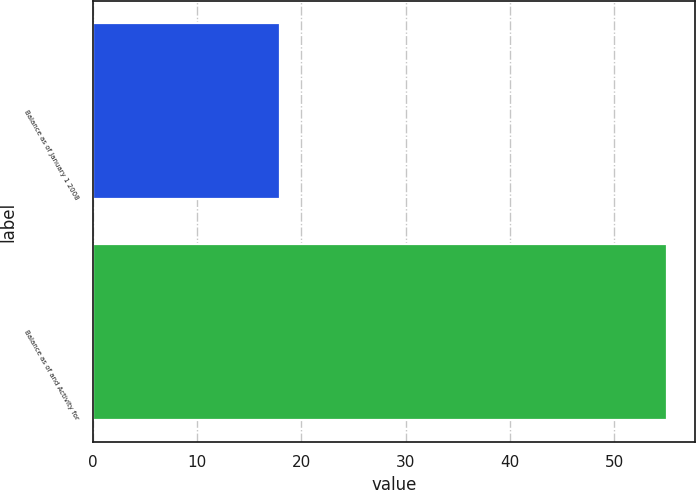Convert chart. <chart><loc_0><loc_0><loc_500><loc_500><bar_chart><fcel>Balance as of January 1 2008<fcel>Balance as of and Activity for<nl><fcel>18<fcel>55<nl></chart> 